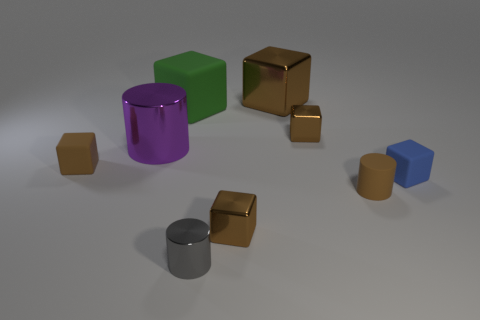Which objects in the image have the same color? The objects with the same color are the two smaller golden cubes, which both share the same metallic sheen and hue. 